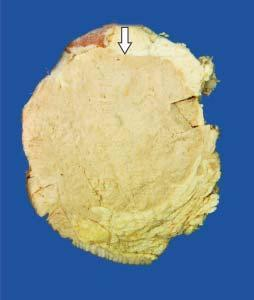what does cut surface of the breast show?
Answer the question using a single word or phrase. A large grey white soft fleshy tumour replacing almost whole of the breast 